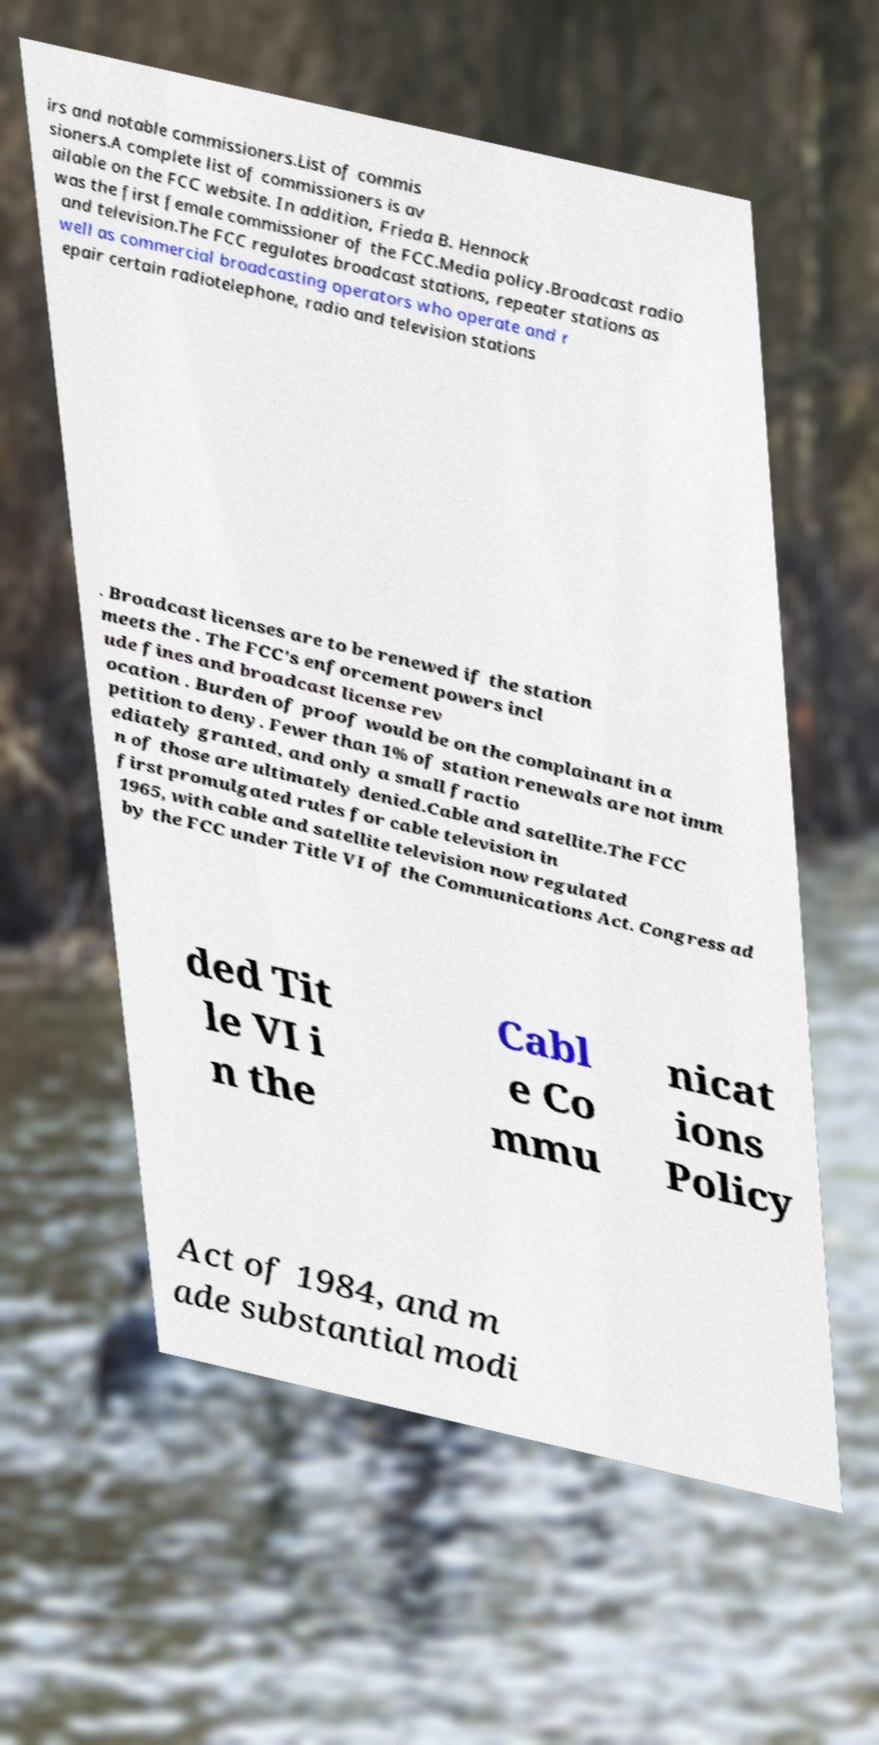What messages or text are displayed in this image? I need them in a readable, typed format. irs and notable commissioners.List of commis sioners.A complete list of commissioners is av ailable on the FCC website. In addition, Frieda B. Hennock was the first female commissioner of the FCC.Media policy.Broadcast radio and television.The FCC regulates broadcast stations, repeater stations as well as commercial broadcasting operators who operate and r epair certain radiotelephone, radio and television stations . Broadcast licenses are to be renewed if the station meets the . The FCC's enforcement powers incl ude fines and broadcast license rev ocation . Burden of proof would be on the complainant in a petition to deny. Fewer than 1% of station renewals are not imm ediately granted, and only a small fractio n of those are ultimately denied.Cable and satellite.The FCC first promulgated rules for cable television in 1965, with cable and satellite television now regulated by the FCC under Title VI of the Communications Act. Congress ad ded Tit le VI i n the Cabl e Co mmu nicat ions Policy Act of 1984, and m ade substantial modi 